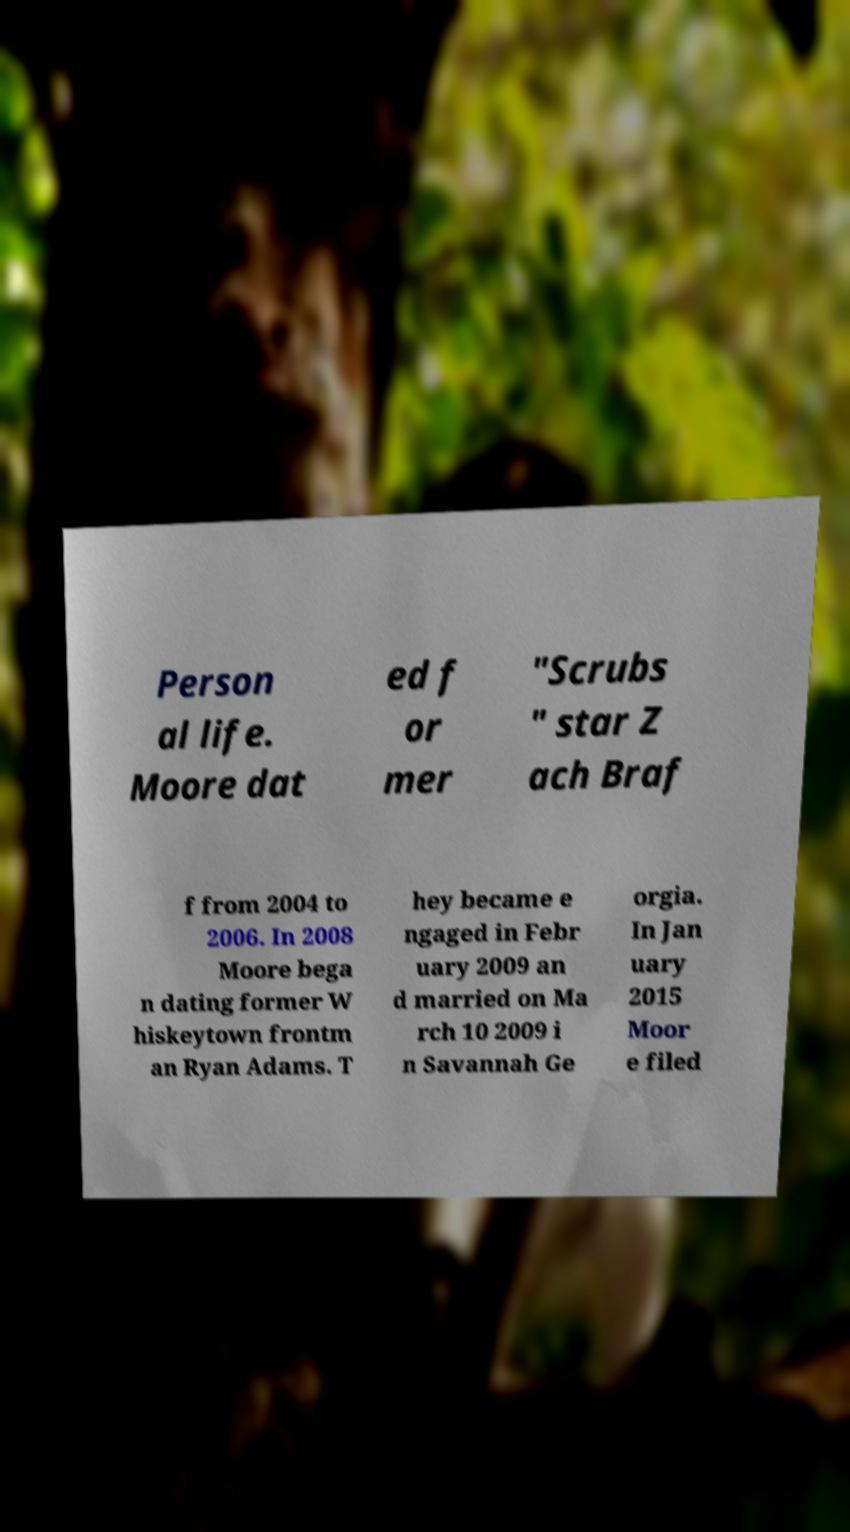Please read and relay the text visible in this image. What does it say? Person al life. Moore dat ed f or mer "Scrubs " star Z ach Braf f from 2004 to 2006. In 2008 Moore bega n dating former W hiskeytown frontm an Ryan Adams. T hey became e ngaged in Febr uary 2009 an d married on Ma rch 10 2009 i n Savannah Ge orgia. In Jan uary 2015 Moor e filed 